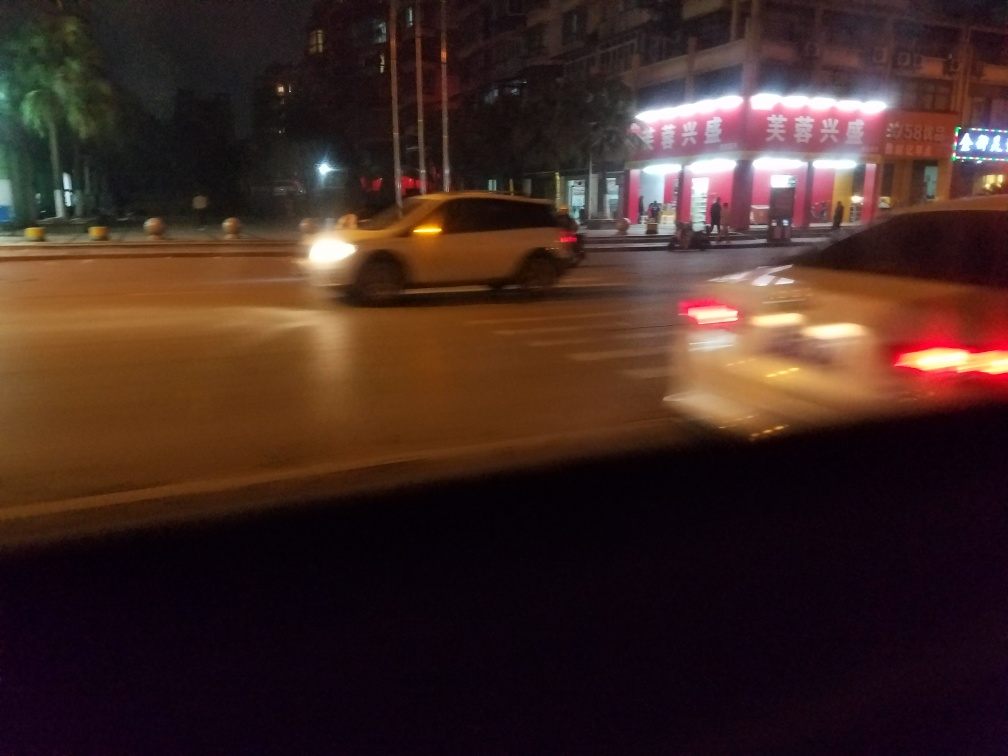Is the background sharp?
A. Yes
B. No
Answer with the option's letter from the given choices directly.
 B. 